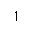<formula> <loc_0><loc_0><loc_500><loc_500>1</formula> 